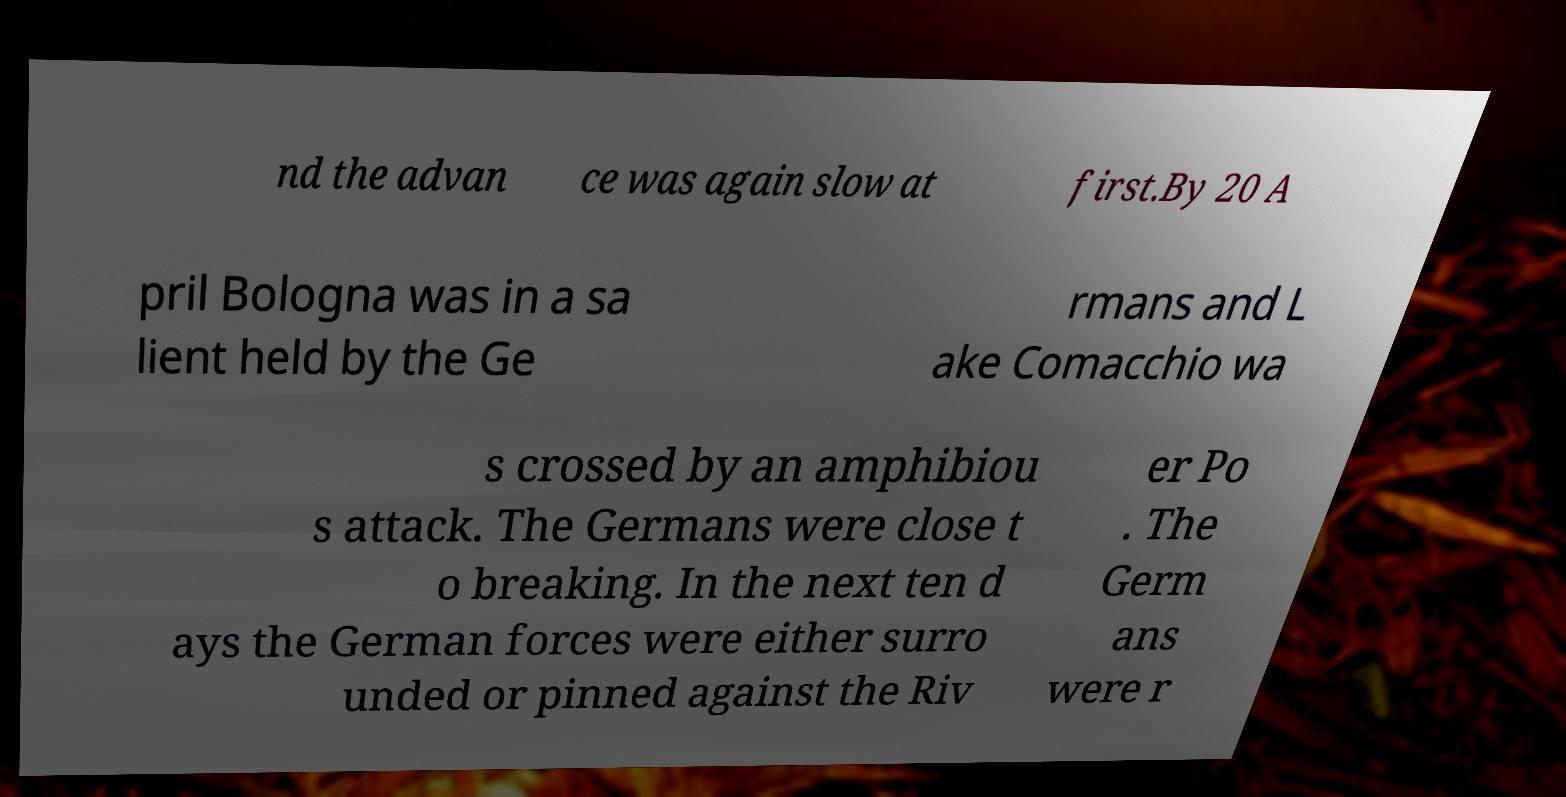Could you assist in decoding the text presented in this image and type it out clearly? nd the advan ce was again slow at first.By 20 A pril Bologna was in a sa lient held by the Ge rmans and L ake Comacchio wa s crossed by an amphibiou s attack. The Germans were close t o breaking. In the next ten d ays the German forces were either surro unded or pinned against the Riv er Po . The Germ ans were r 